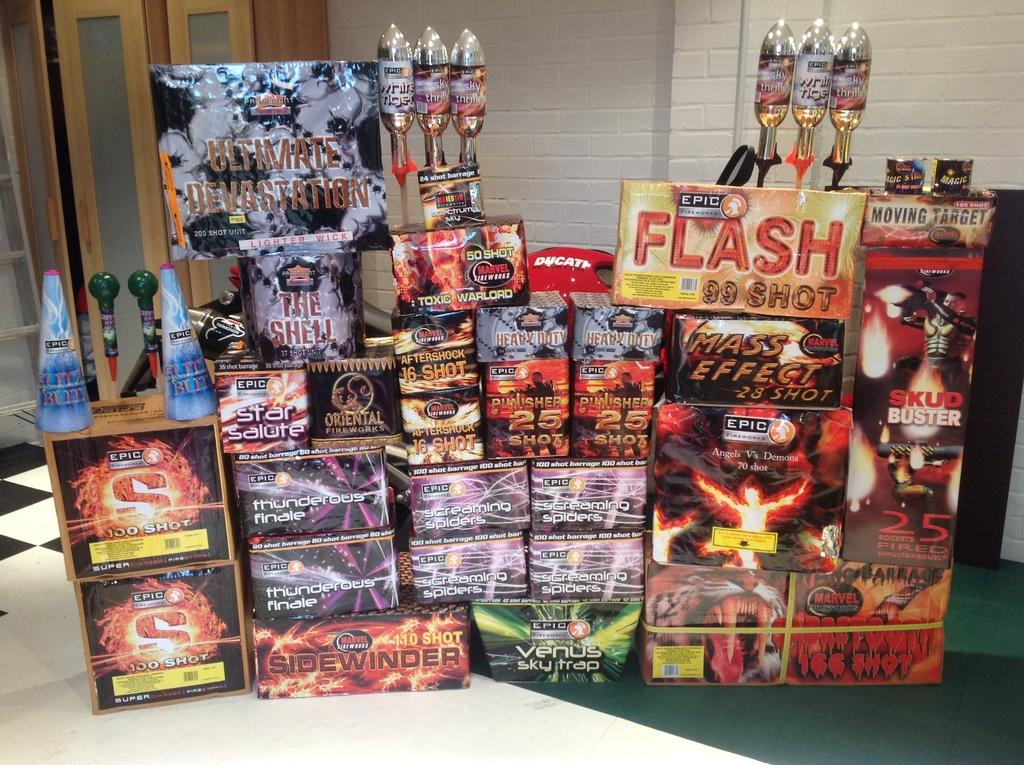<image>
Summarize the visual content of the image. A bunch of Flash Comics such as Screaming Spiders sit on display. 